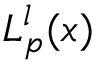<formula> <loc_0><loc_0><loc_500><loc_500>L _ { p } ^ { l } ( x )</formula> 